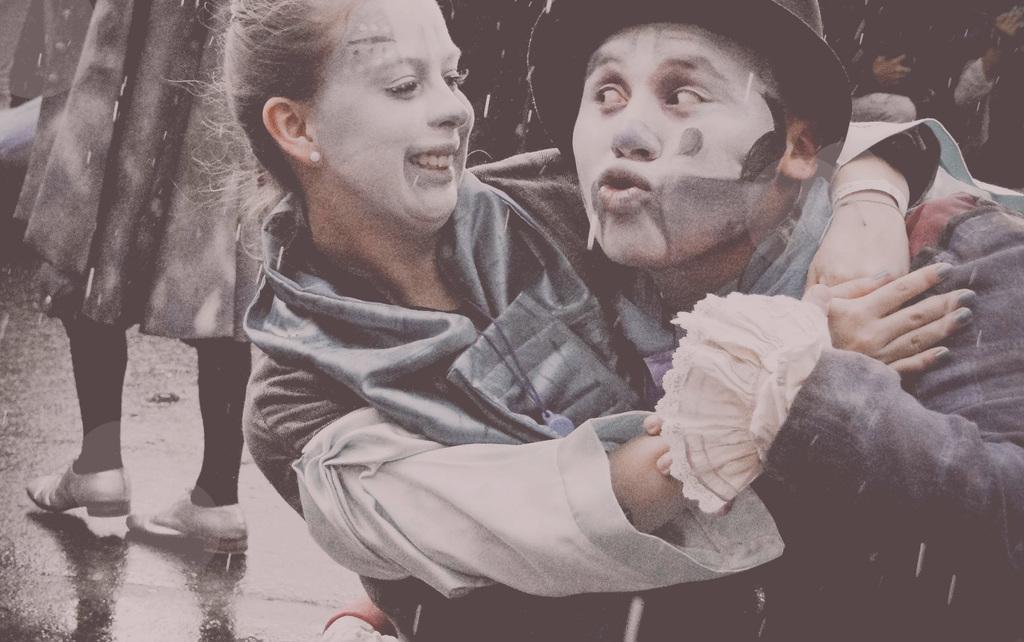Could you give a brief overview of what you see in this image? In the foreground of this image, there is a man and a woman having makeup on their faces and they are hugging. In the background, there are people on the road. 